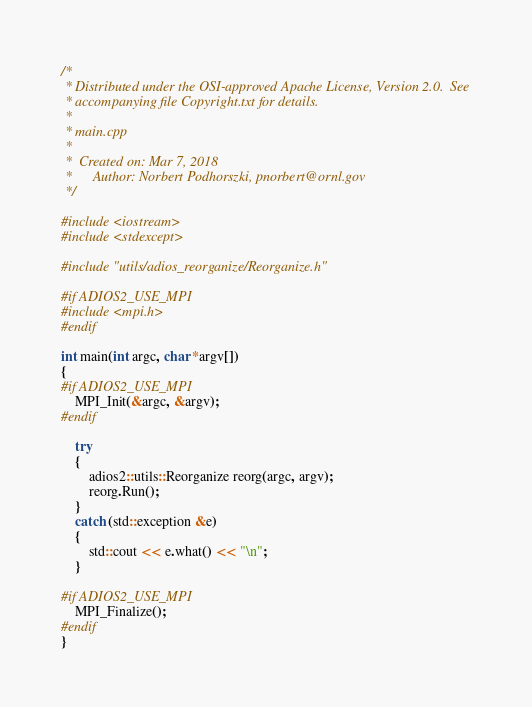Convert code to text. <code><loc_0><loc_0><loc_500><loc_500><_C++_>/*
 * Distributed under the OSI-approved Apache License, Version 2.0.  See
 * accompanying file Copyright.txt for details.
 *
 * main.cpp
 *
 *  Created on: Mar 7, 2018
 *      Author: Norbert Podhorszki, pnorbert@ornl.gov
 */

#include <iostream>
#include <stdexcept>

#include "utils/adios_reorganize/Reorganize.h"

#if ADIOS2_USE_MPI
#include <mpi.h>
#endif

int main(int argc, char *argv[])
{
#if ADIOS2_USE_MPI
    MPI_Init(&argc, &argv);
#endif

    try
    {
        adios2::utils::Reorganize reorg(argc, argv);
        reorg.Run();
    }
    catch (std::exception &e)
    {
        std::cout << e.what() << "\n";
    }

#if ADIOS2_USE_MPI
    MPI_Finalize();
#endif
}
</code> 